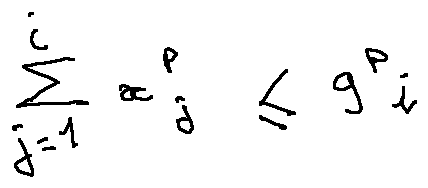Convert formula to latex. <formula><loc_0><loc_0><loc_500><loc_500>\sum \lim i t s _ { j = 1 } ^ { i } x _ { j } ^ { p } \leq 9 ^ { p } i</formula> 